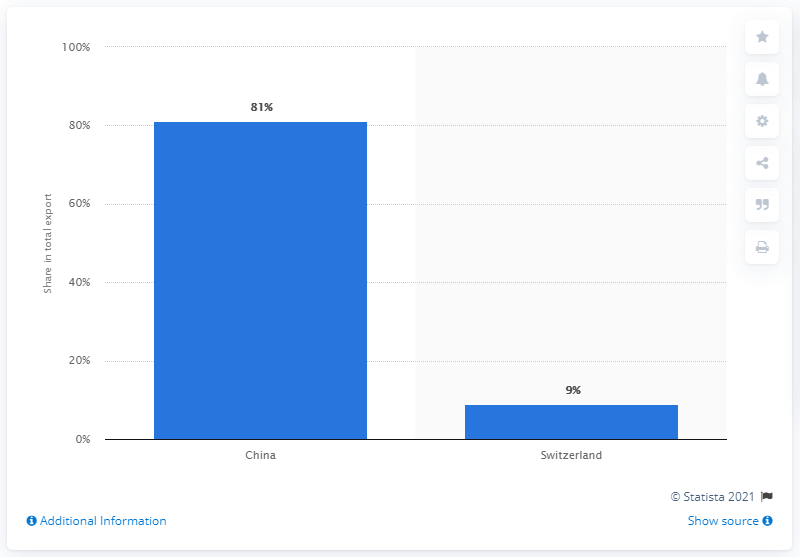Is there any indication of how Mongolia's export partnerships have changed over time? This specific chart doesn't provide a timeline of changes in Mongolia's export partnerships. However, historical data would likely show fluctuations and trends over the years due to economic, political, and market forces affecting trade relations. What might influence these trade relations? Trade relations can be influenced by a multitude of factors, including geopolitical events, domestic economic policies, trade agreements, and changes in supply and demand. For Mongolia, its geographical proximity to China and the resources it has in abundance are key factors. 